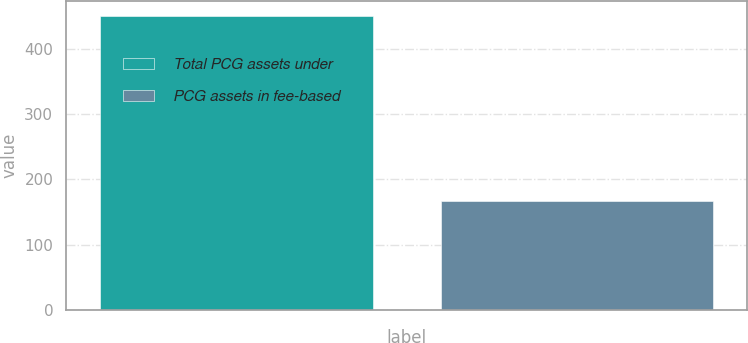Convert chart to OTSL. <chart><loc_0><loc_0><loc_500><loc_500><bar_chart><fcel>Total PCG assets under<fcel>PCG assets in fee-based<nl><fcel>450.6<fcel>167.7<nl></chart> 